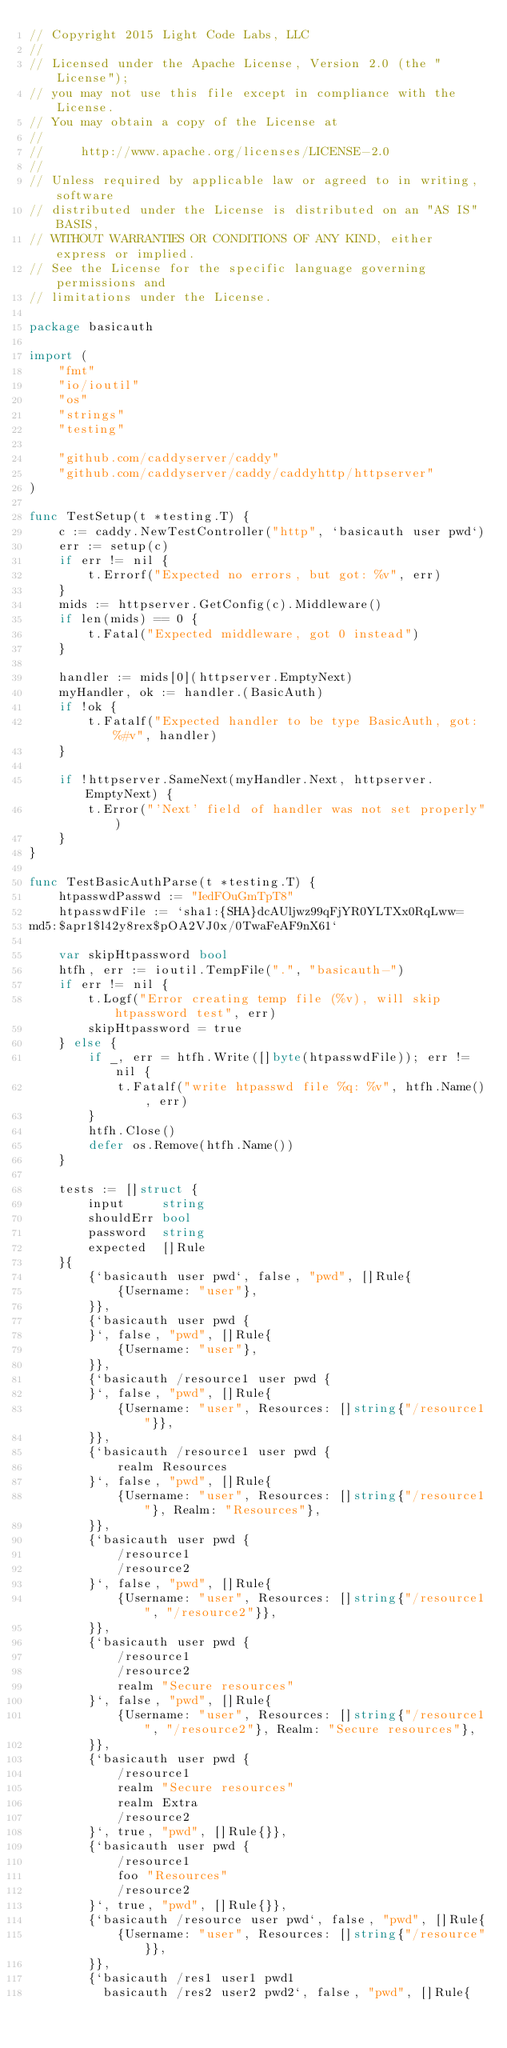Convert code to text. <code><loc_0><loc_0><loc_500><loc_500><_Go_>// Copyright 2015 Light Code Labs, LLC
//
// Licensed under the Apache License, Version 2.0 (the "License");
// you may not use this file except in compliance with the License.
// You may obtain a copy of the License at
//
//     http://www.apache.org/licenses/LICENSE-2.0
//
// Unless required by applicable law or agreed to in writing, software
// distributed under the License is distributed on an "AS IS" BASIS,
// WITHOUT WARRANTIES OR CONDITIONS OF ANY KIND, either express or implied.
// See the License for the specific language governing permissions and
// limitations under the License.

package basicauth

import (
	"fmt"
	"io/ioutil"
	"os"
	"strings"
	"testing"

	"github.com/caddyserver/caddy"
	"github.com/caddyserver/caddy/caddyhttp/httpserver"
)

func TestSetup(t *testing.T) {
	c := caddy.NewTestController("http", `basicauth user pwd`)
	err := setup(c)
	if err != nil {
		t.Errorf("Expected no errors, but got: %v", err)
	}
	mids := httpserver.GetConfig(c).Middleware()
	if len(mids) == 0 {
		t.Fatal("Expected middleware, got 0 instead")
	}

	handler := mids[0](httpserver.EmptyNext)
	myHandler, ok := handler.(BasicAuth)
	if !ok {
		t.Fatalf("Expected handler to be type BasicAuth, got: %#v", handler)
	}

	if !httpserver.SameNext(myHandler.Next, httpserver.EmptyNext) {
		t.Error("'Next' field of handler was not set properly")
	}
}

func TestBasicAuthParse(t *testing.T) {
	htpasswdPasswd := "IedFOuGmTpT8"
	htpasswdFile := `sha1:{SHA}dcAUljwz99qFjYR0YLTXx0RqLww=
md5:$apr1$l42y8rex$pOA2VJ0x/0TwaFeAF9nX61`

	var skipHtpassword bool
	htfh, err := ioutil.TempFile(".", "basicauth-")
	if err != nil {
		t.Logf("Error creating temp file (%v), will skip htpassword test", err)
		skipHtpassword = true
	} else {
		if _, err = htfh.Write([]byte(htpasswdFile)); err != nil {
			t.Fatalf("write htpasswd file %q: %v", htfh.Name(), err)
		}
		htfh.Close()
		defer os.Remove(htfh.Name())
	}

	tests := []struct {
		input     string
		shouldErr bool
		password  string
		expected  []Rule
	}{
		{`basicauth user pwd`, false, "pwd", []Rule{
			{Username: "user"},
		}},
		{`basicauth user pwd {
		}`, false, "pwd", []Rule{
			{Username: "user"},
		}},
		{`basicauth /resource1 user pwd {
		}`, false, "pwd", []Rule{
			{Username: "user", Resources: []string{"/resource1"}},
		}},
		{`basicauth /resource1 user pwd {
			realm Resources
		}`, false, "pwd", []Rule{
			{Username: "user", Resources: []string{"/resource1"}, Realm: "Resources"},
		}},
		{`basicauth user pwd {
			/resource1
			/resource2
		}`, false, "pwd", []Rule{
			{Username: "user", Resources: []string{"/resource1", "/resource2"}},
		}},
		{`basicauth user pwd {
			/resource1
			/resource2
			realm "Secure resources"
		}`, false, "pwd", []Rule{
			{Username: "user", Resources: []string{"/resource1", "/resource2"}, Realm: "Secure resources"},
		}},
		{`basicauth user pwd {
			/resource1
			realm "Secure resources"
			realm Extra
			/resource2
		}`, true, "pwd", []Rule{}},
		{`basicauth user pwd {
			/resource1
			foo "Resources"
			/resource2
		}`, true, "pwd", []Rule{}},
		{`basicauth /resource user pwd`, false, "pwd", []Rule{
			{Username: "user", Resources: []string{"/resource"}},
		}},
		{`basicauth /res1 user1 pwd1
		  basicauth /res2 user2 pwd2`, false, "pwd", []Rule{</code> 